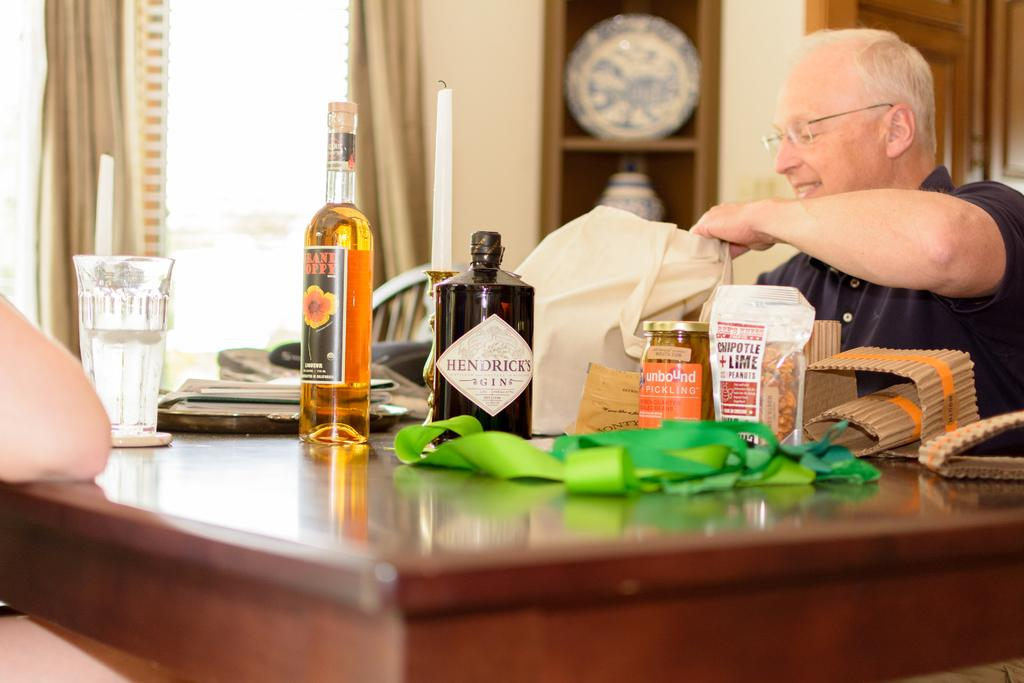What piece of furniture is present in the image? There is a table in the image. What can be seen on the table? There is a glass, a bottle, a candle, a cover, food, and a plate on the table. Who is present in the image? A person is sitting beside the table. What is visible through the window in the image? There is a window in the image, and curtains are associated with it. What type of kite is being played with by the person in the image? There is no kite present in the image; the person is sitting beside the table. What game is the person playing with the table in the image? The person is not playing a game in the image; they are sitting beside the table. 